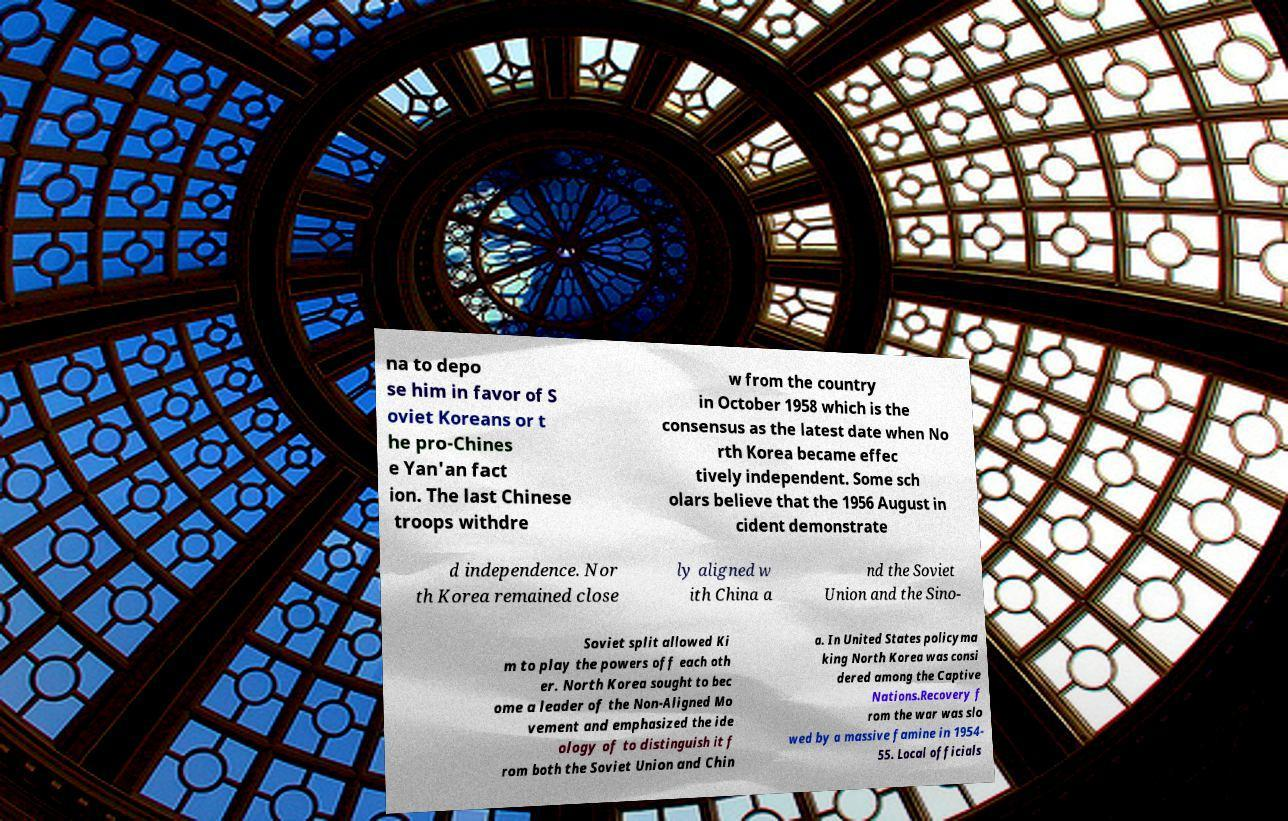What messages or text are displayed in this image? I need them in a readable, typed format. na to depo se him in favor of S oviet Koreans or t he pro-Chines e Yan'an fact ion. The last Chinese troops withdre w from the country in October 1958 which is the consensus as the latest date when No rth Korea became effec tively independent. Some sch olars believe that the 1956 August in cident demonstrate d independence. Nor th Korea remained close ly aligned w ith China a nd the Soviet Union and the Sino- Soviet split allowed Ki m to play the powers off each oth er. North Korea sought to bec ome a leader of the Non-Aligned Mo vement and emphasized the ide ology of to distinguish it f rom both the Soviet Union and Chin a. In United States policyma king North Korea was consi dered among the Captive Nations.Recovery f rom the war was slo wed by a massive famine in 1954- 55. Local officials 